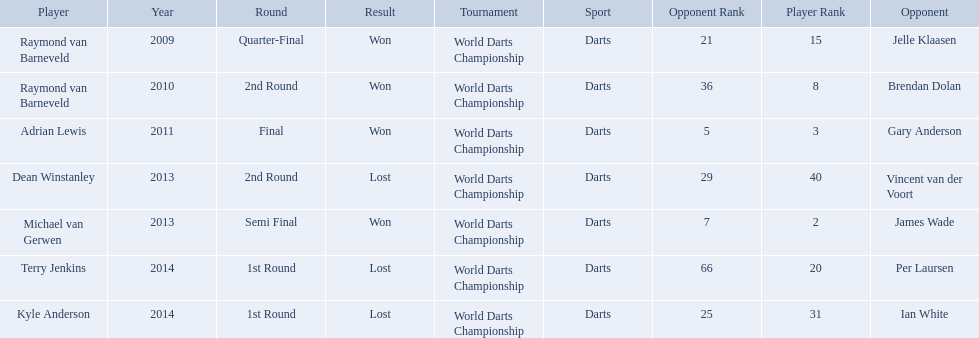Did terry jenkins win in 2014? Terry Jenkins, Lost. If terry jenkins lost who won? Per Laursen. Who were the players in 2014? Terry Jenkins, Kyle Anderson. Did they win or lose? Per Laursen. What players competed in the pdc world darts championship? Raymond van Barneveld, Raymond van Barneveld, Adrian Lewis, Dean Winstanley, Michael van Gerwen, Terry Jenkins, Kyle Anderson. Of these players, who lost? Dean Winstanley, Terry Jenkins, Kyle Anderson. Which of these players lost in 2014? Terry Jenkins, Kyle Anderson. What are the players other than kyle anderson? Terry Jenkins. Can you give me this table as a dict? {'header': ['Player', 'Year', 'Round', 'Result', 'Tournament', 'Sport', 'Opponent Rank', 'Player Rank', 'Opponent'], 'rows': [['Raymond van Barneveld', '2009', 'Quarter-Final', 'Won', 'World Darts Championship', 'Darts', '21', '15', 'Jelle Klaasen'], ['Raymond van Barneveld', '2010', '2nd Round', 'Won', 'World Darts Championship', 'Darts', '36', '8', 'Brendan Dolan'], ['Adrian Lewis', '2011', 'Final', 'Won', 'World Darts Championship', 'Darts', '5', '3', 'Gary Anderson'], ['Dean Winstanley', '2013', '2nd Round', 'Lost', 'World Darts Championship', 'Darts', '29', '40', 'Vincent van der Voort'], ['Michael van Gerwen', '2013', 'Semi Final', 'Won', 'World Darts Championship', 'Darts', '7', '2', 'James Wade'], ['Terry Jenkins', '2014', '1st Round', 'Lost', 'World Darts Championship', 'Darts', '66', '20', 'Per Laursen'], ['Kyle Anderson', '2014', '1st Round', 'Lost', 'World Darts Championship', 'Darts', '25', '31', 'Ian White']]} 